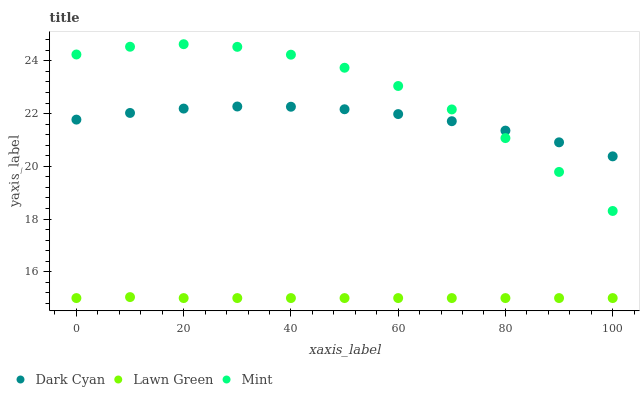Does Lawn Green have the minimum area under the curve?
Answer yes or no. Yes. Does Mint have the maximum area under the curve?
Answer yes or no. Yes. Does Mint have the minimum area under the curve?
Answer yes or no. No. Does Lawn Green have the maximum area under the curve?
Answer yes or no. No. Is Lawn Green the smoothest?
Answer yes or no. Yes. Is Mint the roughest?
Answer yes or no. Yes. Is Mint the smoothest?
Answer yes or no. No. Is Lawn Green the roughest?
Answer yes or no. No. Does Lawn Green have the lowest value?
Answer yes or no. Yes. Does Mint have the lowest value?
Answer yes or no. No. Does Mint have the highest value?
Answer yes or no. Yes. Does Lawn Green have the highest value?
Answer yes or no. No. Is Lawn Green less than Mint?
Answer yes or no. Yes. Is Mint greater than Lawn Green?
Answer yes or no. Yes. Does Dark Cyan intersect Mint?
Answer yes or no. Yes. Is Dark Cyan less than Mint?
Answer yes or no. No. Is Dark Cyan greater than Mint?
Answer yes or no. No. Does Lawn Green intersect Mint?
Answer yes or no. No. 